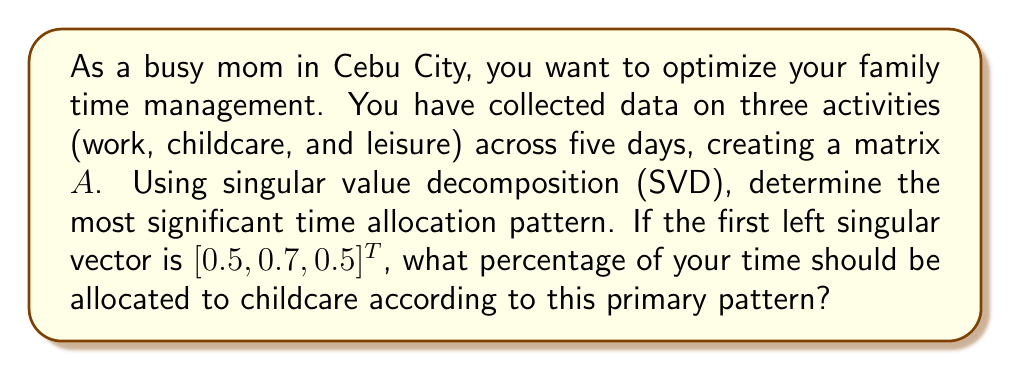Give your solution to this math problem. Let's approach this step-by-step:

1) The singular value decomposition of matrix $A$ is given by:

   $$A = U\Sigma V^T$$

   where $U$ and $V$ are orthogonal matrices and $\Sigma$ is a diagonal matrix of singular values.

2) The columns of $U$ are the left singular vectors, which represent patterns in the row space (activities in this case).

3) We're given that the first left singular vector is:

   $$u_1 = [0.5, 0.7, 0.5]^T$$

4) This vector corresponds to the most significant pattern in time allocation, as it's associated with the largest singular value.

5) To interpret this vector, we need to look at the relative magnitudes of its components:
   - Work: 0.5
   - Childcare: 0.7
   - Leisure: 0.5

6) To convert these to percentages, we sum the absolute values and divide each by the sum:

   $$\text{Sum} = |0.5| + |0.7| + |0.5| = 1.7$$

7) Childcare percentage:

   $$\frac{0.7}{1.7} \times 100\% \approx 41.18\%$$

Thus, according to this primary time allocation pattern, approximately 41.18% of time should be allocated to childcare.
Answer: 41.18% 